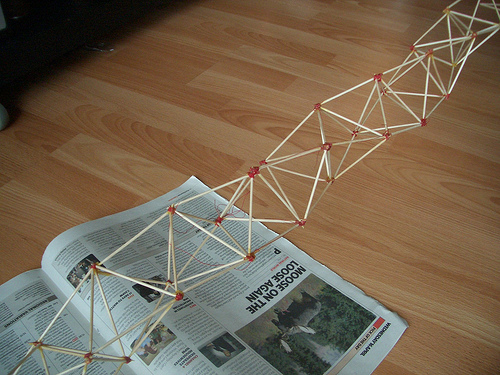<image>
Can you confirm if the stick sculpture is above the magazine? Yes. The stick sculpture is positioned above the magazine in the vertical space, higher up in the scene. 